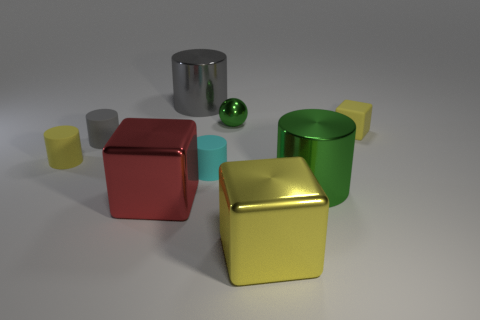What is the material of the small cylinder that is the same color as the tiny matte block?
Keep it short and to the point. Rubber. There is a cylinder that is the same color as the ball; what is its size?
Make the answer very short. Large. Is there anything else that has the same material as the sphere?
Ensure brevity in your answer.  Yes. There is a large metal cylinder in front of the small metallic ball; are there any big cylinders left of it?
Ensure brevity in your answer.  Yes. What number of things are cylinders that are behind the small metal sphere or metal blocks that are on the left side of the cyan cylinder?
Offer a very short reply. 2. Is there anything else that is the same color as the matte block?
Make the answer very short. Yes. There is a cube that is behind the metallic block left of the gray metal cylinder that is behind the small yellow matte cube; what is its color?
Your response must be concise. Yellow. There is a shiny cylinder that is behind the tiny yellow rubber thing that is on the left side of the small yellow cube; what size is it?
Ensure brevity in your answer.  Large. There is a large thing that is both behind the red shiny thing and in front of the tiny yellow matte cylinder; what material is it?
Offer a terse response. Metal. Do the green metal sphere and the yellow matte thing to the right of the large red metallic block have the same size?
Give a very brief answer. Yes. 